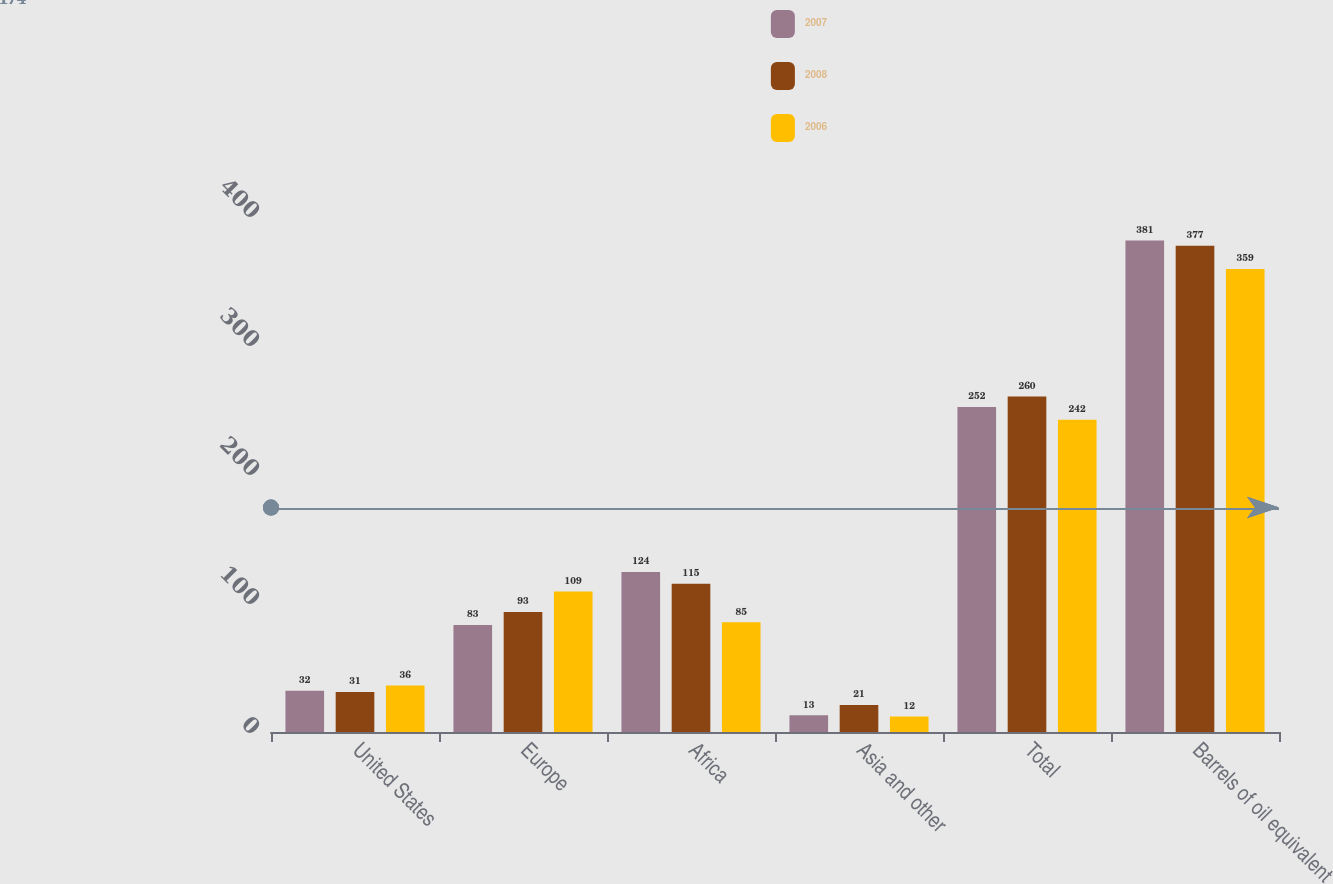<chart> <loc_0><loc_0><loc_500><loc_500><stacked_bar_chart><ecel><fcel>United States<fcel>Europe<fcel>Africa<fcel>Asia and other<fcel>Total<fcel>Barrels of oil equivalent<nl><fcel>2007<fcel>32<fcel>83<fcel>124<fcel>13<fcel>252<fcel>381<nl><fcel>2008<fcel>31<fcel>93<fcel>115<fcel>21<fcel>260<fcel>377<nl><fcel>2006<fcel>36<fcel>109<fcel>85<fcel>12<fcel>242<fcel>359<nl></chart> 